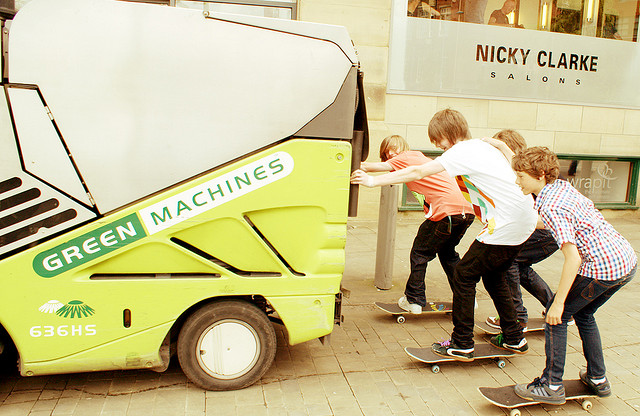Identify the text displayed in this image. MACHINES GREEN 636HS CLARKER NICKY wrapit S A L O N S 